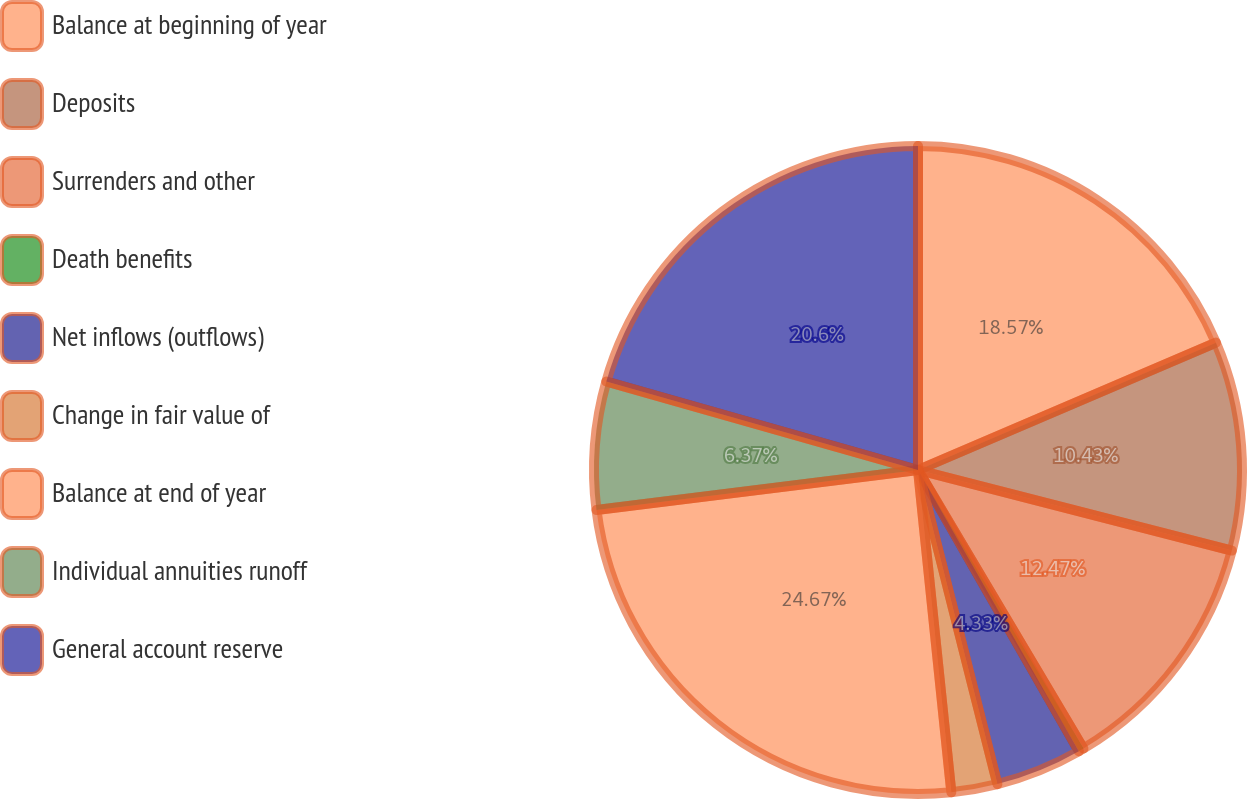<chart> <loc_0><loc_0><loc_500><loc_500><pie_chart><fcel>Balance at beginning of year<fcel>Deposits<fcel>Surrenders and other<fcel>Death benefits<fcel>Net inflows (outflows)<fcel>Change in fair value of<fcel>Balance at end of year<fcel>Individual annuities runoff<fcel>General account reserve<nl><fcel>18.57%<fcel>10.43%<fcel>12.47%<fcel>0.26%<fcel>4.33%<fcel>2.3%<fcel>24.67%<fcel>6.37%<fcel>20.6%<nl></chart> 